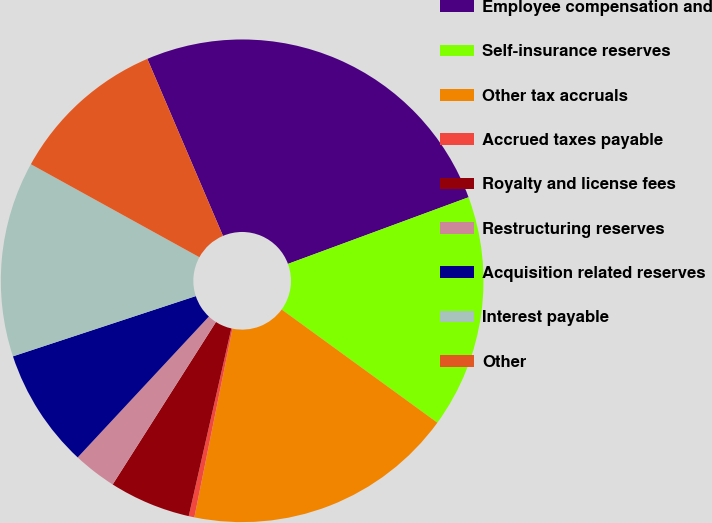Convert chart to OTSL. <chart><loc_0><loc_0><loc_500><loc_500><pie_chart><fcel>Employee compensation and<fcel>Self-insurance reserves<fcel>Other tax accruals<fcel>Accrued taxes payable<fcel>Royalty and license fees<fcel>Restructuring reserves<fcel>Acquisition related reserves<fcel>Interest payable<fcel>Other<nl><fcel>25.8%<fcel>15.63%<fcel>18.17%<fcel>0.38%<fcel>5.46%<fcel>2.92%<fcel>8.0%<fcel>13.09%<fcel>10.55%<nl></chart> 